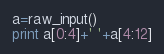Convert code to text. <code><loc_0><loc_0><loc_500><loc_500><_Python_>a=raw_input()
print a[0:4]+' '+a[4:12]</code> 